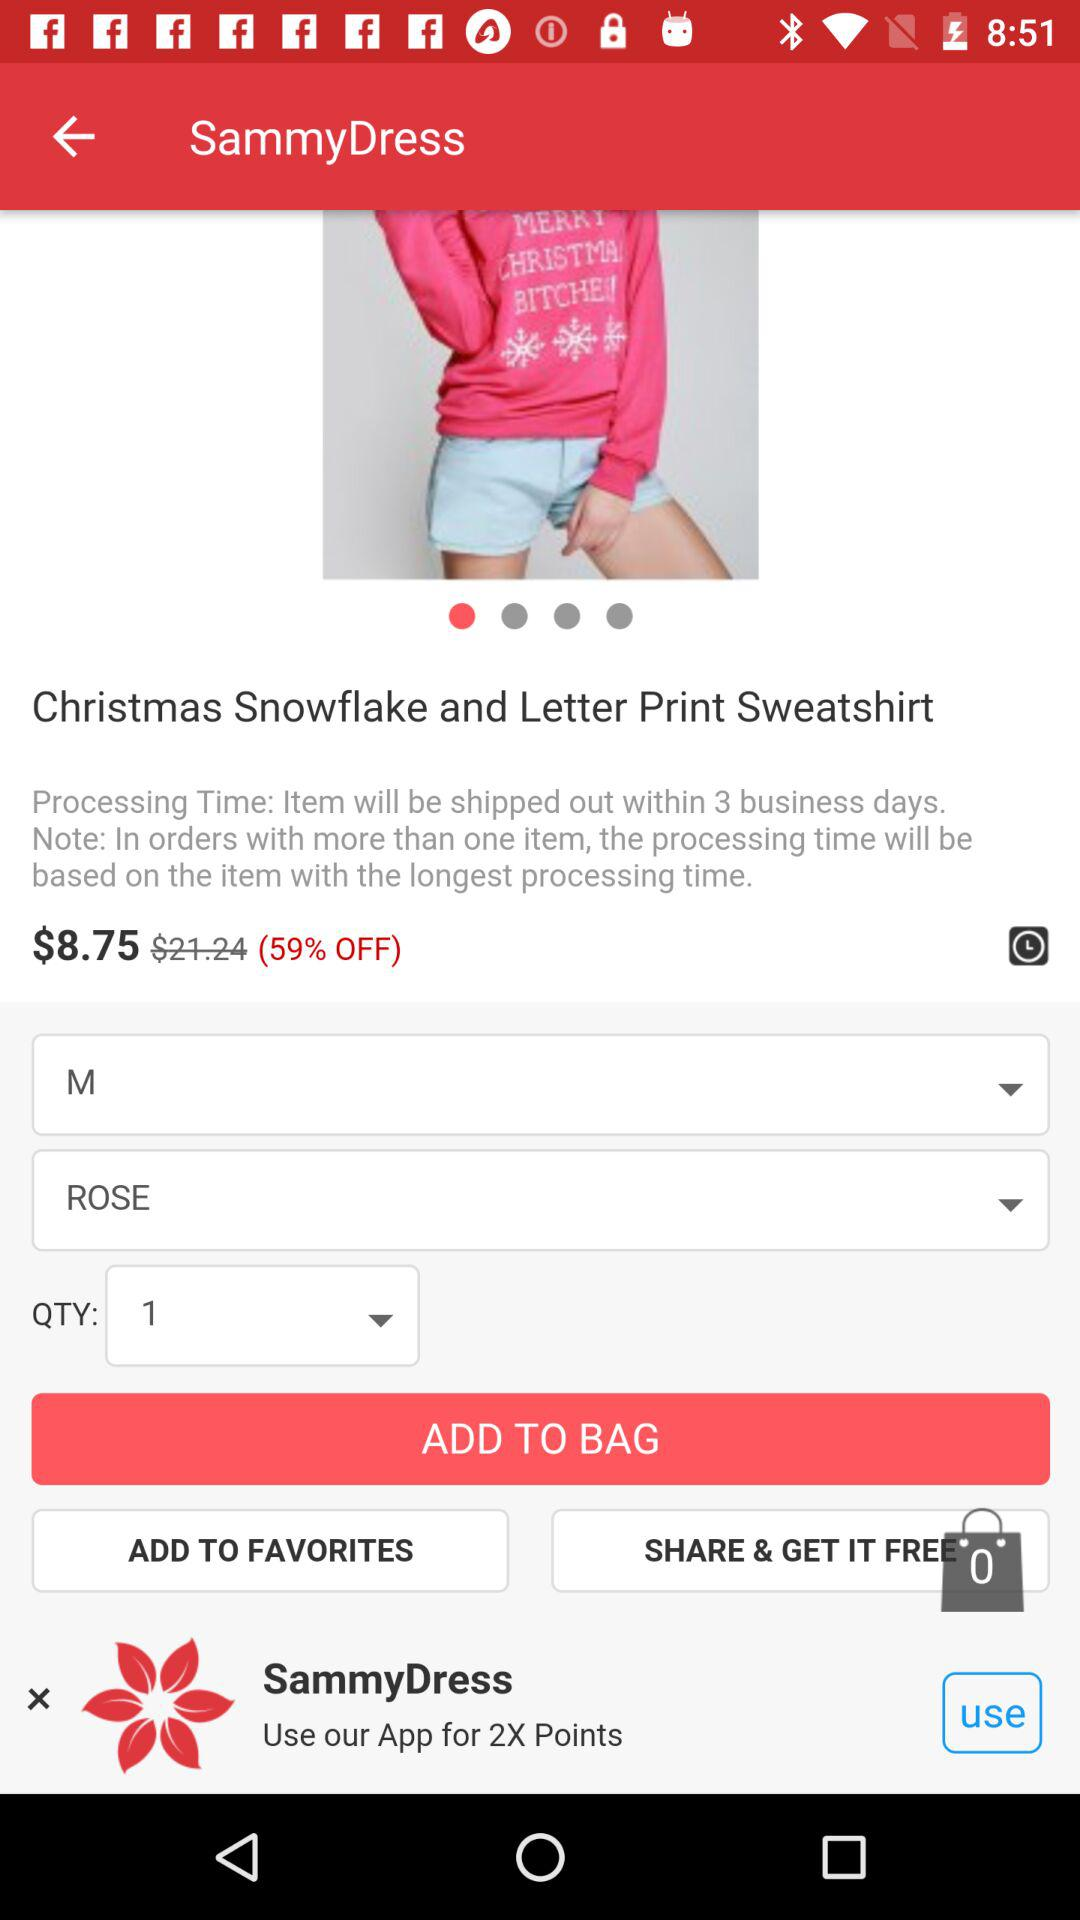How many items are in the cart?
Answer the question using a single word or phrase. 1 